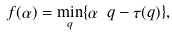<formula> <loc_0><loc_0><loc_500><loc_500>f ( \alpha ) = \min _ { q } \{ \alpha \ q - \tau ( q ) \} ,</formula> 